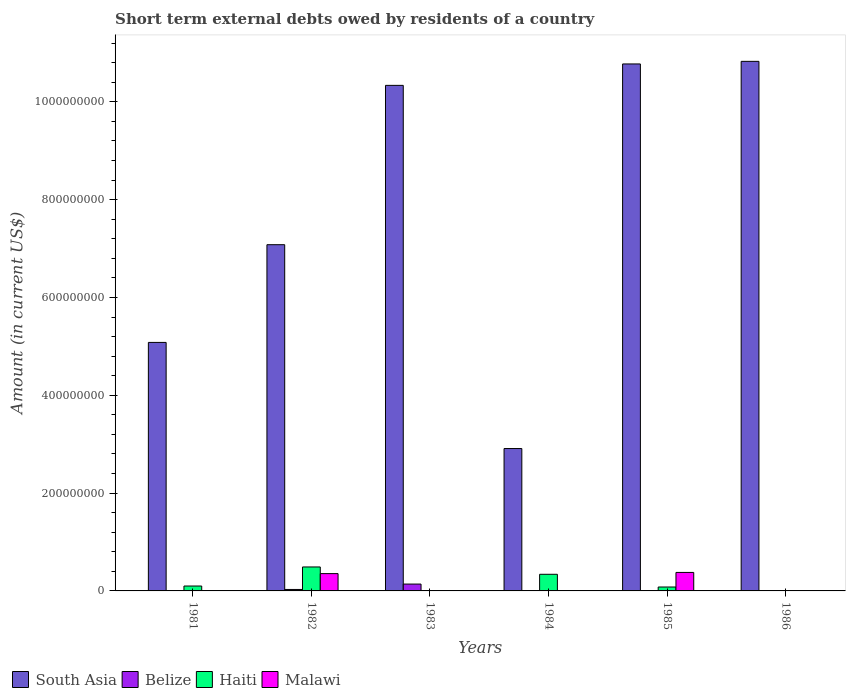How many different coloured bars are there?
Your answer should be compact. 4. Are the number of bars per tick equal to the number of legend labels?
Your response must be concise. No. Are the number of bars on each tick of the X-axis equal?
Your answer should be very brief. No. How many bars are there on the 2nd tick from the left?
Make the answer very short. 4. How many bars are there on the 5th tick from the right?
Give a very brief answer. 4. What is the amount of short-term external debts owed by residents in South Asia in 1982?
Provide a short and direct response. 7.08e+08. Across all years, what is the maximum amount of short-term external debts owed by residents in Haiti?
Provide a short and direct response. 4.90e+07. What is the total amount of short-term external debts owed by residents in Haiti in the graph?
Offer a terse response. 1.01e+08. What is the difference between the amount of short-term external debts owed by residents in Belize in 1982 and that in 1983?
Your response must be concise. -1.10e+07. What is the difference between the amount of short-term external debts owed by residents in Belize in 1982 and the amount of short-term external debts owed by residents in South Asia in 1985?
Your response must be concise. -1.07e+09. What is the average amount of short-term external debts owed by residents in Malawi per year?
Your response must be concise. 1.22e+07. In the year 1985, what is the difference between the amount of short-term external debts owed by residents in Malawi and amount of short-term external debts owed by residents in Haiti?
Offer a terse response. 2.98e+07. What is the ratio of the amount of short-term external debts owed by residents in South Asia in 1984 to that in 1985?
Offer a terse response. 0.27. What is the difference between the highest and the second highest amount of short-term external debts owed by residents in Malawi?
Give a very brief answer. 2.44e+06. What is the difference between the highest and the lowest amount of short-term external debts owed by residents in Belize?
Offer a very short reply. 1.40e+07. How many bars are there?
Keep it short and to the point. 15. How many years are there in the graph?
Make the answer very short. 6. What is the difference between two consecutive major ticks on the Y-axis?
Your answer should be very brief. 2.00e+08. Does the graph contain any zero values?
Offer a very short reply. Yes. Does the graph contain grids?
Provide a succinct answer. No. How many legend labels are there?
Your response must be concise. 4. How are the legend labels stacked?
Ensure brevity in your answer.  Horizontal. What is the title of the graph?
Your answer should be very brief. Short term external debts owed by residents of a country. Does "Low income" appear as one of the legend labels in the graph?
Ensure brevity in your answer.  No. What is the label or title of the X-axis?
Your answer should be very brief. Years. What is the Amount (in current US$) in South Asia in 1981?
Your answer should be compact. 5.08e+08. What is the Amount (in current US$) in Belize in 1981?
Provide a succinct answer. 0. What is the Amount (in current US$) in Haiti in 1981?
Your answer should be very brief. 1.00e+07. What is the Amount (in current US$) in South Asia in 1982?
Provide a short and direct response. 7.08e+08. What is the Amount (in current US$) in Belize in 1982?
Offer a very short reply. 3.00e+06. What is the Amount (in current US$) in Haiti in 1982?
Make the answer very short. 4.90e+07. What is the Amount (in current US$) in Malawi in 1982?
Your answer should be very brief. 3.54e+07. What is the Amount (in current US$) of South Asia in 1983?
Your response must be concise. 1.03e+09. What is the Amount (in current US$) of Belize in 1983?
Your answer should be compact. 1.40e+07. What is the Amount (in current US$) of South Asia in 1984?
Your answer should be compact. 2.91e+08. What is the Amount (in current US$) of Belize in 1984?
Ensure brevity in your answer.  0. What is the Amount (in current US$) in Haiti in 1984?
Give a very brief answer. 3.40e+07. What is the Amount (in current US$) of Malawi in 1984?
Provide a succinct answer. 0. What is the Amount (in current US$) in South Asia in 1985?
Keep it short and to the point. 1.08e+09. What is the Amount (in current US$) of Malawi in 1985?
Ensure brevity in your answer.  3.78e+07. What is the Amount (in current US$) of South Asia in 1986?
Make the answer very short. 1.08e+09. What is the Amount (in current US$) of Malawi in 1986?
Your answer should be very brief. 2.25e+05. Across all years, what is the maximum Amount (in current US$) of South Asia?
Offer a very short reply. 1.08e+09. Across all years, what is the maximum Amount (in current US$) of Belize?
Keep it short and to the point. 1.40e+07. Across all years, what is the maximum Amount (in current US$) in Haiti?
Your answer should be compact. 4.90e+07. Across all years, what is the maximum Amount (in current US$) in Malawi?
Keep it short and to the point. 3.78e+07. Across all years, what is the minimum Amount (in current US$) of South Asia?
Ensure brevity in your answer.  2.91e+08. What is the total Amount (in current US$) in South Asia in the graph?
Your response must be concise. 4.70e+09. What is the total Amount (in current US$) in Belize in the graph?
Make the answer very short. 1.70e+07. What is the total Amount (in current US$) of Haiti in the graph?
Your answer should be very brief. 1.01e+08. What is the total Amount (in current US$) in Malawi in the graph?
Provide a succinct answer. 7.34e+07. What is the difference between the Amount (in current US$) of South Asia in 1981 and that in 1982?
Offer a very short reply. -2.00e+08. What is the difference between the Amount (in current US$) in Haiti in 1981 and that in 1982?
Offer a very short reply. -3.90e+07. What is the difference between the Amount (in current US$) in South Asia in 1981 and that in 1983?
Your answer should be very brief. -5.26e+08. What is the difference between the Amount (in current US$) of South Asia in 1981 and that in 1984?
Ensure brevity in your answer.  2.17e+08. What is the difference between the Amount (in current US$) in Haiti in 1981 and that in 1984?
Give a very brief answer. -2.40e+07. What is the difference between the Amount (in current US$) in South Asia in 1981 and that in 1985?
Provide a short and direct response. -5.69e+08. What is the difference between the Amount (in current US$) in Haiti in 1981 and that in 1985?
Your answer should be compact. 2.00e+06. What is the difference between the Amount (in current US$) in South Asia in 1981 and that in 1986?
Ensure brevity in your answer.  -5.75e+08. What is the difference between the Amount (in current US$) in South Asia in 1982 and that in 1983?
Provide a short and direct response. -3.26e+08. What is the difference between the Amount (in current US$) of Belize in 1982 and that in 1983?
Your answer should be very brief. -1.10e+07. What is the difference between the Amount (in current US$) in South Asia in 1982 and that in 1984?
Make the answer very short. 4.17e+08. What is the difference between the Amount (in current US$) of Haiti in 1982 and that in 1984?
Your response must be concise. 1.50e+07. What is the difference between the Amount (in current US$) in South Asia in 1982 and that in 1985?
Give a very brief answer. -3.70e+08. What is the difference between the Amount (in current US$) in Haiti in 1982 and that in 1985?
Your answer should be very brief. 4.10e+07. What is the difference between the Amount (in current US$) in Malawi in 1982 and that in 1985?
Offer a terse response. -2.44e+06. What is the difference between the Amount (in current US$) of South Asia in 1982 and that in 1986?
Offer a very short reply. -3.75e+08. What is the difference between the Amount (in current US$) in Malawi in 1982 and that in 1986?
Give a very brief answer. 3.52e+07. What is the difference between the Amount (in current US$) of South Asia in 1983 and that in 1984?
Give a very brief answer. 7.43e+08. What is the difference between the Amount (in current US$) in South Asia in 1983 and that in 1985?
Make the answer very short. -4.38e+07. What is the difference between the Amount (in current US$) of South Asia in 1983 and that in 1986?
Offer a terse response. -4.91e+07. What is the difference between the Amount (in current US$) of South Asia in 1984 and that in 1985?
Your response must be concise. -7.86e+08. What is the difference between the Amount (in current US$) of Haiti in 1984 and that in 1985?
Offer a terse response. 2.60e+07. What is the difference between the Amount (in current US$) in South Asia in 1984 and that in 1986?
Offer a very short reply. -7.92e+08. What is the difference between the Amount (in current US$) of South Asia in 1985 and that in 1986?
Provide a short and direct response. -5.31e+06. What is the difference between the Amount (in current US$) in Malawi in 1985 and that in 1986?
Your answer should be very brief. 3.76e+07. What is the difference between the Amount (in current US$) of South Asia in 1981 and the Amount (in current US$) of Belize in 1982?
Ensure brevity in your answer.  5.05e+08. What is the difference between the Amount (in current US$) in South Asia in 1981 and the Amount (in current US$) in Haiti in 1982?
Provide a short and direct response. 4.59e+08. What is the difference between the Amount (in current US$) of South Asia in 1981 and the Amount (in current US$) of Malawi in 1982?
Provide a short and direct response. 4.73e+08. What is the difference between the Amount (in current US$) of Haiti in 1981 and the Amount (in current US$) of Malawi in 1982?
Your answer should be compact. -2.54e+07. What is the difference between the Amount (in current US$) of South Asia in 1981 and the Amount (in current US$) of Belize in 1983?
Your response must be concise. 4.94e+08. What is the difference between the Amount (in current US$) of South Asia in 1981 and the Amount (in current US$) of Haiti in 1984?
Offer a terse response. 4.74e+08. What is the difference between the Amount (in current US$) in South Asia in 1981 and the Amount (in current US$) in Haiti in 1985?
Your answer should be compact. 5.00e+08. What is the difference between the Amount (in current US$) of South Asia in 1981 and the Amount (in current US$) of Malawi in 1985?
Your answer should be compact. 4.70e+08. What is the difference between the Amount (in current US$) in Haiti in 1981 and the Amount (in current US$) in Malawi in 1985?
Provide a short and direct response. -2.78e+07. What is the difference between the Amount (in current US$) in South Asia in 1981 and the Amount (in current US$) in Malawi in 1986?
Keep it short and to the point. 5.08e+08. What is the difference between the Amount (in current US$) in Haiti in 1981 and the Amount (in current US$) in Malawi in 1986?
Ensure brevity in your answer.  9.78e+06. What is the difference between the Amount (in current US$) in South Asia in 1982 and the Amount (in current US$) in Belize in 1983?
Offer a very short reply. 6.94e+08. What is the difference between the Amount (in current US$) in South Asia in 1982 and the Amount (in current US$) in Haiti in 1984?
Your answer should be very brief. 6.74e+08. What is the difference between the Amount (in current US$) in Belize in 1982 and the Amount (in current US$) in Haiti in 1984?
Offer a terse response. -3.10e+07. What is the difference between the Amount (in current US$) of South Asia in 1982 and the Amount (in current US$) of Haiti in 1985?
Keep it short and to the point. 7.00e+08. What is the difference between the Amount (in current US$) in South Asia in 1982 and the Amount (in current US$) in Malawi in 1985?
Make the answer very short. 6.70e+08. What is the difference between the Amount (in current US$) in Belize in 1982 and the Amount (in current US$) in Haiti in 1985?
Keep it short and to the point. -5.00e+06. What is the difference between the Amount (in current US$) of Belize in 1982 and the Amount (in current US$) of Malawi in 1985?
Keep it short and to the point. -3.48e+07. What is the difference between the Amount (in current US$) of Haiti in 1982 and the Amount (in current US$) of Malawi in 1985?
Your response must be concise. 1.12e+07. What is the difference between the Amount (in current US$) in South Asia in 1982 and the Amount (in current US$) in Malawi in 1986?
Your answer should be compact. 7.08e+08. What is the difference between the Amount (in current US$) of Belize in 1982 and the Amount (in current US$) of Malawi in 1986?
Your answer should be compact. 2.78e+06. What is the difference between the Amount (in current US$) in Haiti in 1982 and the Amount (in current US$) in Malawi in 1986?
Keep it short and to the point. 4.88e+07. What is the difference between the Amount (in current US$) in South Asia in 1983 and the Amount (in current US$) in Haiti in 1984?
Offer a very short reply. 1.00e+09. What is the difference between the Amount (in current US$) of Belize in 1983 and the Amount (in current US$) of Haiti in 1984?
Your answer should be very brief. -2.00e+07. What is the difference between the Amount (in current US$) in South Asia in 1983 and the Amount (in current US$) in Haiti in 1985?
Keep it short and to the point. 1.03e+09. What is the difference between the Amount (in current US$) of South Asia in 1983 and the Amount (in current US$) of Malawi in 1985?
Provide a succinct answer. 9.96e+08. What is the difference between the Amount (in current US$) of Belize in 1983 and the Amount (in current US$) of Malawi in 1985?
Provide a succinct answer. -2.38e+07. What is the difference between the Amount (in current US$) in South Asia in 1983 and the Amount (in current US$) in Malawi in 1986?
Offer a very short reply. 1.03e+09. What is the difference between the Amount (in current US$) of Belize in 1983 and the Amount (in current US$) of Malawi in 1986?
Make the answer very short. 1.38e+07. What is the difference between the Amount (in current US$) in South Asia in 1984 and the Amount (in current US$) in Haiti in 1985?
Your response must be concise. 2.83e+08. What is the difference between the Amount (in current US$) of South Asia in 1984 and the Amount (in current US$) of Malawi in 1985?
Provide a short and direct response. 2.53e+08. What is the difference between the Amount (in current US$) of Haiti in 1984 and the Amount (in current US$) of Malawi in 1985?
Provide a succinct answer. -3.82e+06. What is the difference between the Amount (in current US$) in South Asia in 1984 and the Amount (in current US$) in Malawi in 1986?
Offer a very short reply. 2.91e+08. What is the difference between the Amount (in current US$) in Haiti in 1984 and the Amount (in current US$) in Malawi in 1986?
Give a very brief answer. 3.38e+07. What is the difference between the Amount (in current US$) in South Asia in 1985 and the Amount (in current US$) in Malawi in 1986?
Keep it short and to the point. 1.08e+09. What is the difference between the Amount (in current US$) of Haiti in 1985 and the Amount (in current US$) of Malawi in 1986?
Offer a very short reply. 7.78e+06. What is the average Amount (in current US$) in South Asia per year?
Ensure brevity in your answer.  7.84e+08. What is the average Amount (in current US$) of Belize per year?
Give a very brief answer. 2.83e+06. What is the average Amount (in current US$) in Haiti per year?
Give a very brief answer. 1.68e+07. What is the average Amount (in current US$) of Malawi per year?
Your answer should be compact. 1.22e+07. In the year 1981, what is the difference between the Amount (in current US$) of South Asia and Amount (in current US$) of Haiti?
Provide a succinct answer. 4.98e+08. In the year 1982, what is the difference between the Amount (in current US$) of South Asia and Amount (in current US$) of Belize?
Your answer should be compact. 7.05e+08. In the year 1982, what is the difference between the Amount (in current US$) of South Asia and Amount (in current US$) of Haiti?
Offer a very short reply. 6.59e+08. In the year 1982, what is the difference between the Amount (in current US$) of South Asia and Amount (in current US$) of Malawi?
Offer a terse response. 6.73e+08. In the year 1982, what is the difference between the Amount (in current US$) of Belize and Amount (in current US$) of Haiti?
Offer a terse response. -4.60e+07. In the year 1982, what is the difference between the Amount (in current US$) in Belize and Amount (in current US$) in Malawi?
Make the answer very short. -3.24e+07. In the year 1982, what is the difference between the Amount (in current US$) of Haiti and Amount (in current US$) of Malawi?
Offer a terse response. 1.36e+07. In the year 1983, what is the difference between the Amount (in current US$) of South Asia and Amount (in current US$) of Belize?
Keep it short and to the point. 1.02e+09. In the year 1984, what is the difference between the Amount (in current US$) of South Asia and Amount (in current US$) of Haiti?
Provide a short and direct response. 2.57e+08. In the year 1985, what is the difference between the Amount (in current US$) of South Asia and Amount (in current US$) of Haiti?
Provide a short and direct response. 1.07e+09. In the year 1985, what is the difference between the Amount (in current US$) of South Asia and Amount (in current US$) of Malawi?
Your response must be concise. 1.04e+09. In the year 1985, what is the difference between the Amount (in current US$) in Haiti and Amount (in current US$) in Malawi?
Your response must be concise. -2.98e+07. In the year 1986, what is the difference between the Amount (in current US$) of South Asia and Amount (in current US$) of Malawi?
Make the answer very short. 1.08e+09. What is the ratio of the Amount (in current US$) in South Asia in 1981 to that in 1982?
Offer a terse response. 0.72. What is the ratio of the Amount (in current US$) of Haiti in 1981 to that in 1982?
Keep it short and to the point. 0.2. What is the ratio of the Amount (in current US$) in South Asia in 1981 to that in 1983?
Your answer should be compact. 0.49. What is the ratio of the Amount (in current US$) in South Asia in 1981 to that in 1984?
Offer a very short reply. 1.75. What is the ratio of the Amount (in current US$) of Haiti in 1981 to that in 1984?
Make the answer very short. 0.29. What is the ratio of the Amount (in current US$) in South Asia in 1981 to that in 1985?
Offer a terse response. 0.47. What is the ratio of the Amount (in current US$) in South Asia in 1981 to that in 1986?
Give a very brief answer. 0.47. What is the ratio of the Amount (in current US$) of South Asia in 1982 to that in 1983?
Your answer should be very brief. 0.68. What is the ratio of the Amount (in current US$) of Belize in 1982 to that in 1983?
Make the answer very short. 0.21. What is the ratio of the Amount (in current US$) of South Asia in 1982 to that in 1984?
Keep it short and to the point. 2.43. What is the ratio of the Amount (in current US$) in Haiti in 1982 to that in 1984?
Provide a succinct answer. 1.44. What is the ratio of the Amount (in current US$) in South Asia in 1982 to that in 1985?
Keep it short and to the point. 0.66. What is the ratio of the Amount (in current US$) of Haiti in 1982 to that in 1985?
Make the answer very short. 6.12. What is the ratio of the Amount (in current US$) of Malawi in 1982 to that in 1985?
Provide a succinct answer. 0.94. What is the ratio of the Amount (in current US$) of South Asia in 1982 to that in 1986?
Provide a short and direct response. 0.65. What is the ratio of the Amount (in current US$) of Malawi in 1982 to that in 1986?
Your response must be concise. 157.24. What is the ratio of the Amount (in current US$) in South Asia in 1983 to that in 1984?
Your answer should be very brief. 3.55. What is the ratio of the Amount (in current US$) of South Asia in 1983 to that in 1985?
Your answer should be very brief. 0.96. What is the ratio of the Amount (in current US$) of South Asia in 1983 to that in 1986?
Your answer should be compact. 0.95. What is the ratio of the Amount (in current US$) of South Asia in 1984 to that in 1985?
Offer a very short reply. 0.27. What is the ratio of the Amount (in current US$) of Haiti in 1984 to that in 1985?
Your answer should be very brief. 4.25. What is the ratio of the Amount (in current US$) of South Asia in 1984 to that in 1986?
Give a very brief answer. 0.27. What is the ratio of the Amount (in current US$) in South Asia in 1985 to that in 1986?
Ensure brevity in your answer.  1. What is the ratio of the Amount (in current US$) in Malawi in 1985 to that in 1986?
Give a very brief answer. 168.1. What is the difference between the highest and the second highest Amount (in current US$) of South Asia?
Your response must be concise. 5.31e+06. What is the difference between the highest and the second highest Amount (in current US$) in Haiti?
Provide a short and direct response. 1.50e+07. What is the difference between the highest and the second highest Amount (in current US$) of Malawi?
Your answer should be very brief. 2.44e+06. What is the difference between the highest and the lowest Amount (in current US$) of South Asia?
Keep it short and to the point. 7.92e+08. What is the difference between the highest and the lowest Amount (in current US$) in Belize?
Make the answer very short. 1.40e+07. What is the difference between the highest and the lowest Amount (in current US$) in Haiti?
Your answer should be very brief. 4.90e+07. What is the difference between the highest and the lowest Amount (in current US$) of Malawi?
Ensure brevity in your answer.  3.78e+07. 